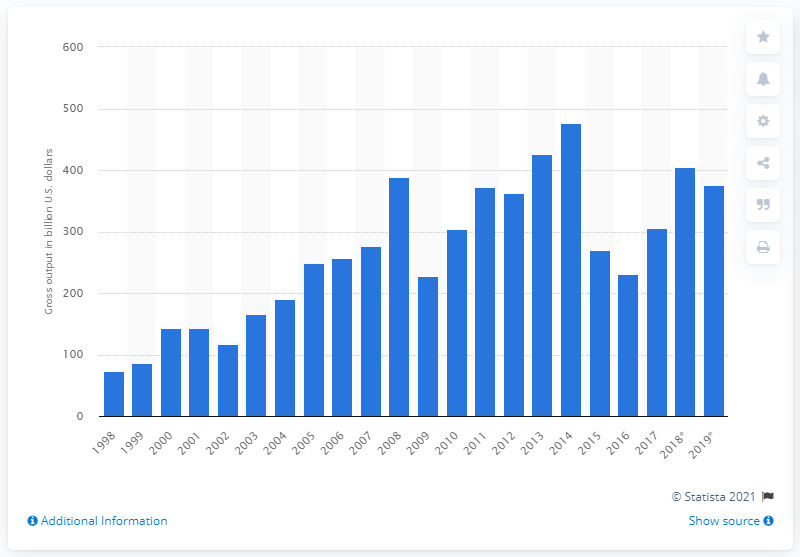Give some essential details in this illustration. The gross output of the U.S. oil and gas extraction industry in 2019 was approximately 375.2 billion dollars. 